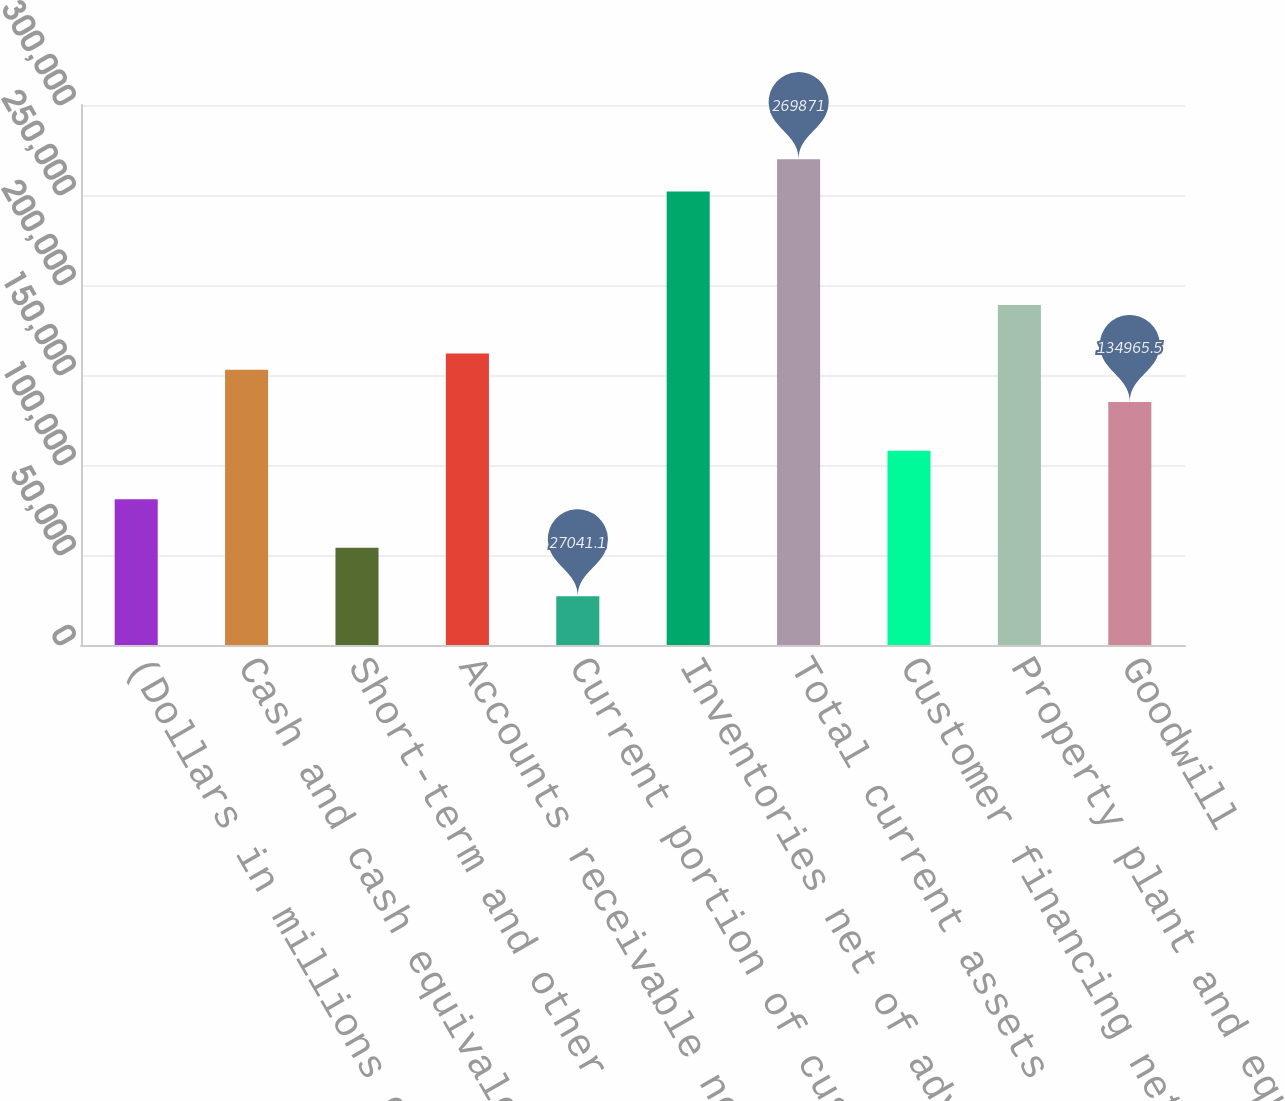<chart> <loc_0><loc_0><loc_500><loc_500><bar_chart><fcel>(Dollars in millions except<fcel>Cash and cash equivalents<fcel>Short-term and other<fcel>Accounts receivable net<fcel>Current portion of customer<fcel>Inventories net of advances<fcel>Total current assets<fcel>Customer financing net<fcel>Property plant and equipment<fcel>Goodwill<nl><fcel>81003.3<fcel>152953<fcel>54022.2<fcel>161947<fcel>27041.1<fcel>251884<fcel>269871<fcel>107984<fcel>188928<fcel>134966<nl></chart> 